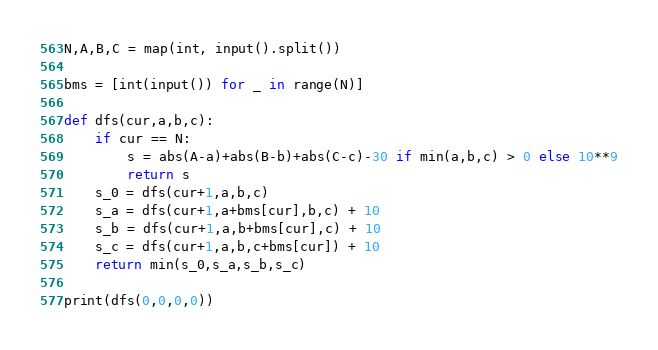<code> <loc_0><loc_0><loc_500><loc_500><_Python_>N,A,B,C = map(int, input().split())

bms = [int(input()) for _ in range(N)]

def dfs(cur,a,b,c):
    if cur == N:
        s = abs(A-a)+abs(B-b)+abs(C-c)-30 if min(a,b,c) > 0 else 10**9
        return s
    s_0 = dfs(cur+1,a,b,c)
    s_a = dfs(cur+1,a+bms[cur],b,c) + 10
    s_b = dfs(cur+1,a,b+bms[cur],c) + 10
    s_c = dfs(cur+1,a,b,c+bms[cur]) + 10
    return min(s_0,s_a,s_b,s_c)

print(dfs(0,0,0,0))</code> 